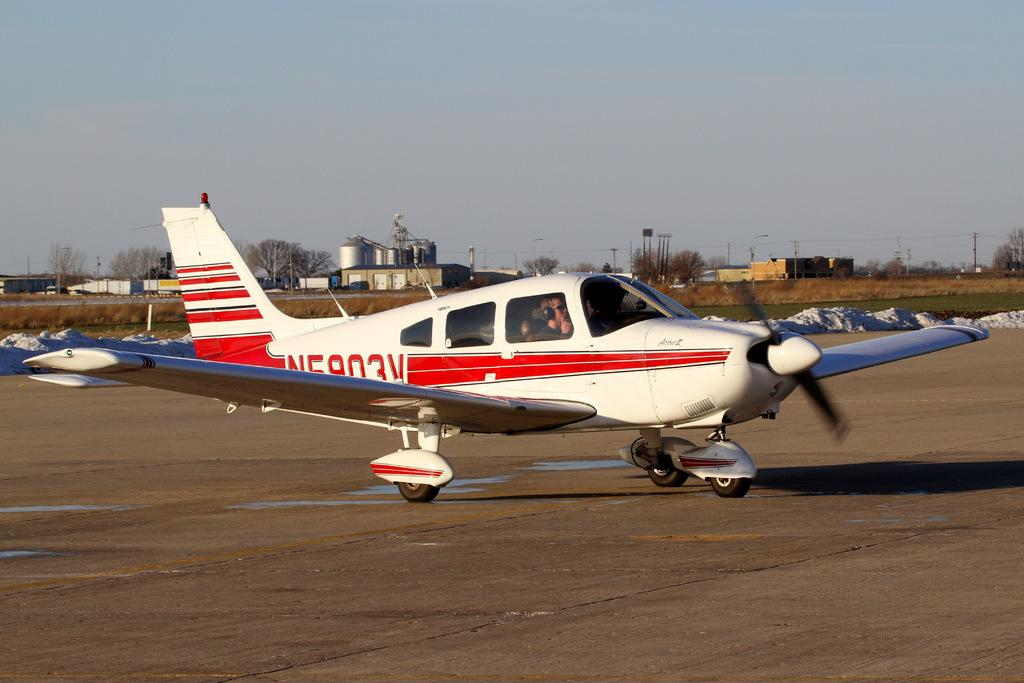<image>
Create a compact narrative representing the image presented. White airplane with a red stripe and the number 3 on it. 